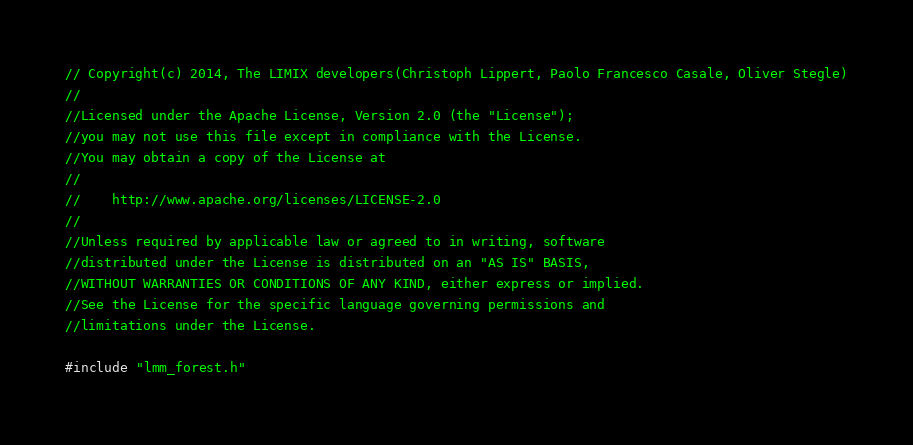<code> <loc_0><loc_0><loc_500><loc_500><_C++_>// Copyright(c) 2014, The LIMIX developers(Christoph Lippert, Paolo Francesco Casale, Oliver Stegle)
//
//Licensed under the Apache License, Version 2.0 (the "License");
//you may not use this file except in compliance with the License.
//You may obtain a copy of the License at
//
//    http://www.apache.org/licenses/LICENSE-2.0
//
//Unless required by applicable law or agreed to in writing, software
//distributed under the License is distributed on an "AS IS" BASIS,
//WITHOUT WARRANTIES OR CONDITIONS OF ANY KIND, either express or implied.
//See the License for the specific language governing permissions and
//limitations under the License.

#include "lmm_forest.h"
</code> 